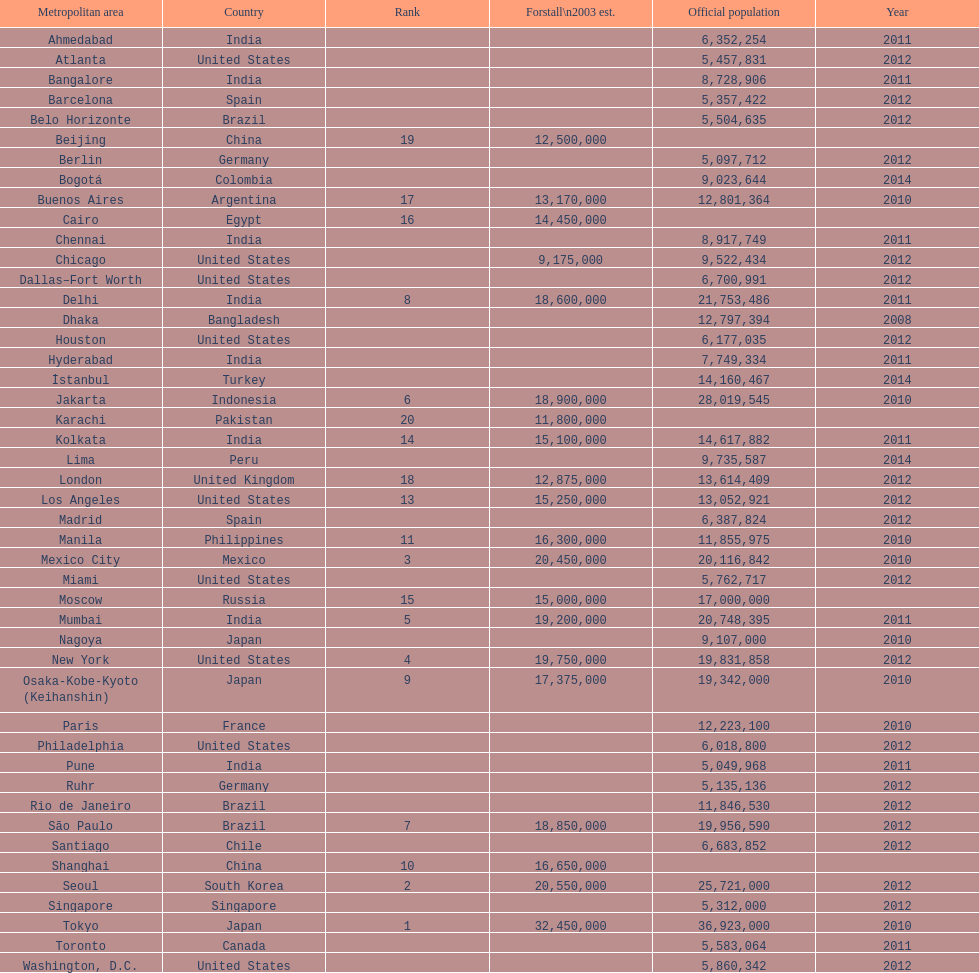Name a city from the same country as bangalore. Ahmedabad. 